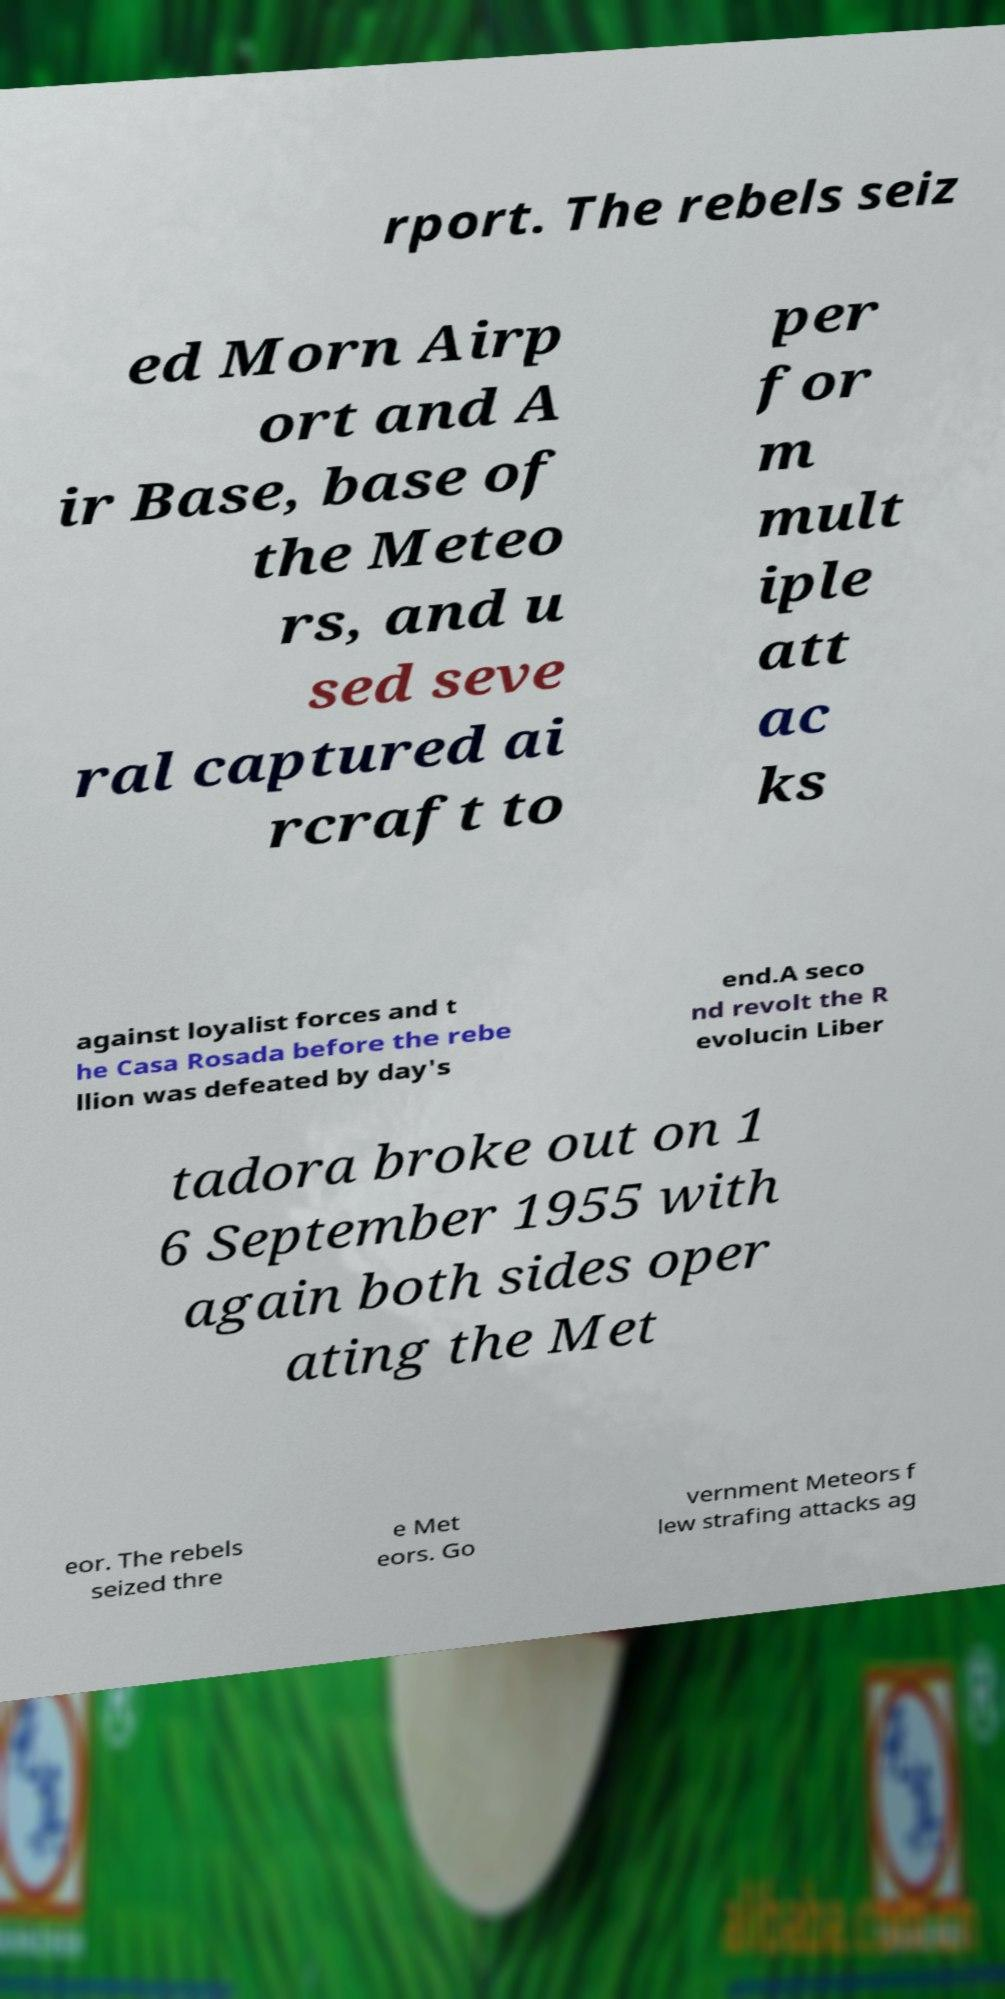Can you read and provide the text displayed in the image?This photo seems to have some interesting text. Can you extract and type it out for me? rport. The rebels seiz ed Morn Airp ort and A ir Base, base of the Meteo rs, and u sed seve ral captured ai rcraft to per for m mult iple att ac ks against loyalist forces and t he Casa Rosada before the rebe llion was defeated by day's end.A seco nd revolt the R evolucin Liber tadora broke out on 1 6 September 1955 with again both sides oper ating the Met eor. The rebels seized thre e Met eors. Go vernment Meteors f lew strafing attacks ag 